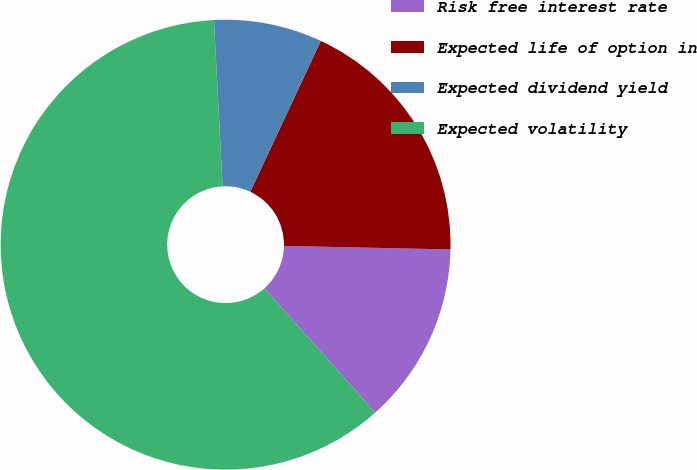Convert chart to OTSL. <chart><loc_0><loc_0><loc_500><loc_500><pie_chart><fcel>Risk free interest rate<fcel>Expected life of option in<fcel>Expected dividend yield<fcel>Expected volatility<nl><fcel>13.08%<fcel>18.38%<fcel>7.78%<fcel>60.76%<nl></chart> 